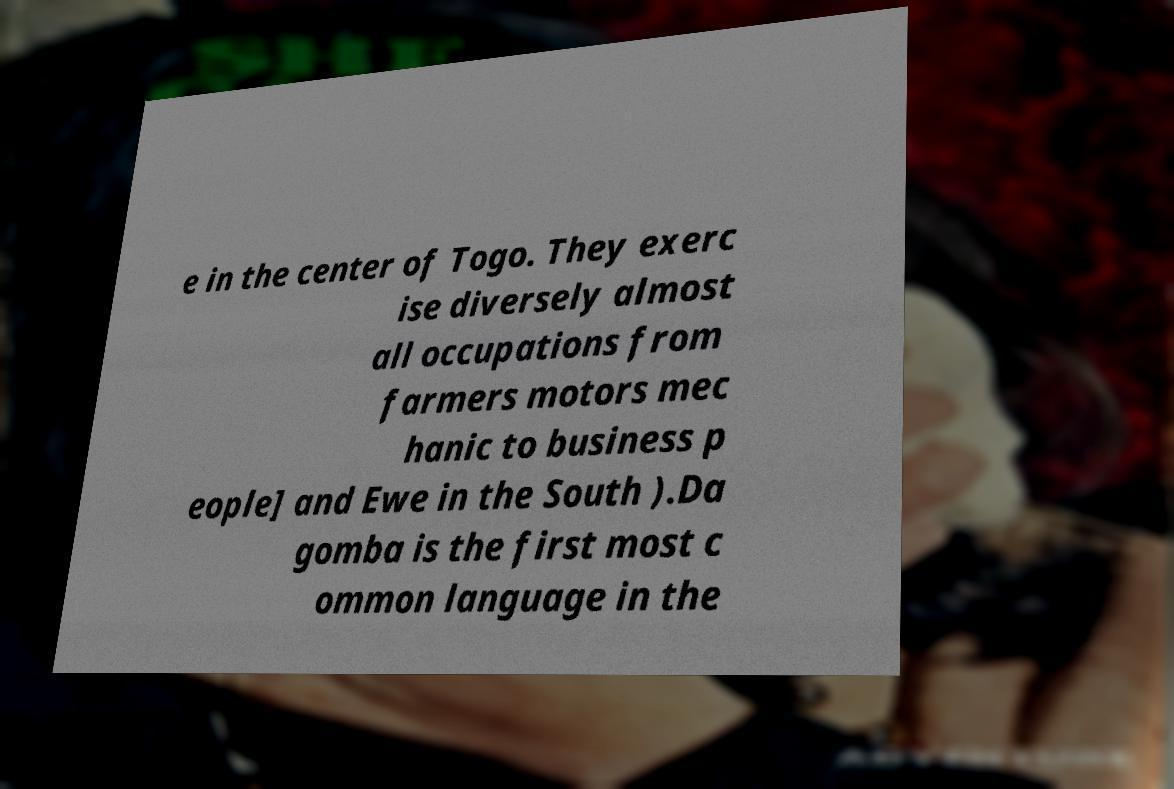Can you read and provide the text displayed in the image?This photo seems to have some interesting text. Can you extract and type it out for me? e in the center of Togo. They exerc ise diversely almost all occupations from farmers motors mec hanic to business p eople] and Ewe in the South ).Da gomba is the first most c ommon language in the 